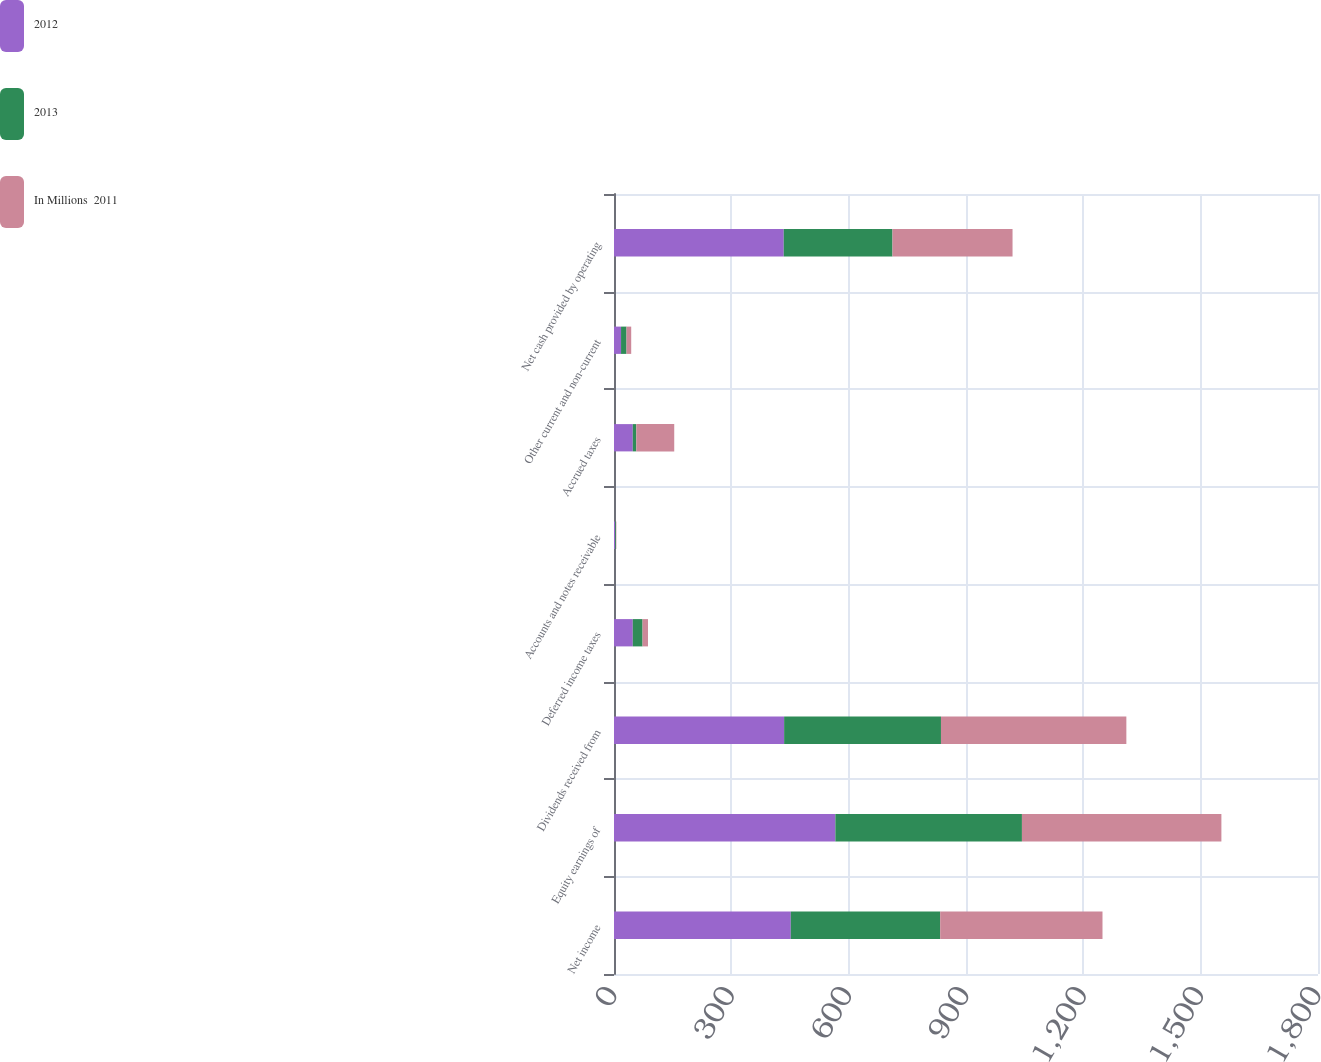Convert chart. <chart><loc_0><loc_0><loc_500><loc_500><stacked_bar_chart><ecel><fcel>Net income<fcel>Equity earnings of<fcel>Dividends received from<fcel>Deferred income taxes<fcel>Accounts and notes receivable<fcel>Accrued taxes<fcel>Other current and non-current<fcel>Net cash provided by operating<nl><fcel>2012<fcel>452<fcel>566<fcel>435<fcel>48<fcel>3<fcel>48<fcel>18<fcel>434<nl><fcel>2013<fcel>382<fcel>477<fcel>401<fcel>25<fcel>2<fcel>9<fcel>14<fcel>278<nl><fcel>In Millions  2011<fcel>415<fcel>510<fcel>474<fcel>14<fcel>1<fcel>97<fcel>12<fcel>307<nl></chart> 